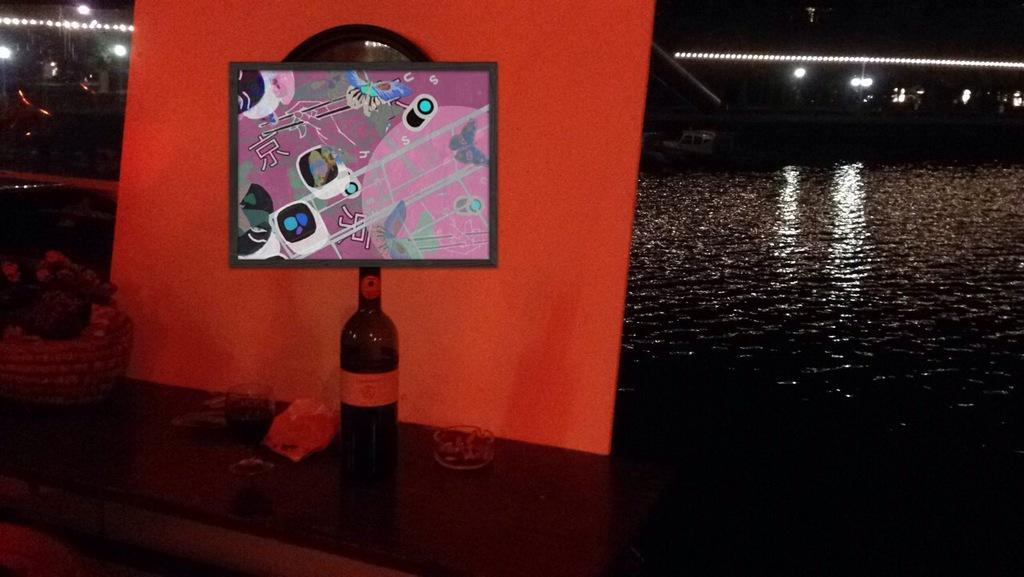What can be seen hanging on the wall in the image? There is a poster in the image. What type of beverage is visible in the image? There is bottled water in the image. What is providing illumination in the image? There are lights in the image. What are the long, thin objects in the image? There are rods in the image. Can you describe the unspecified objects in the image? Unfortunately, the provided facts do not specify the nature of these objects. What is the color of the background in the image? The background of the image is dark. Can you tell me who won the argument in the image? There is no argument present in the image, so it is not possible to determine a winner. What type of hair is visible on the top of the image? There is no hair visible in the image. 